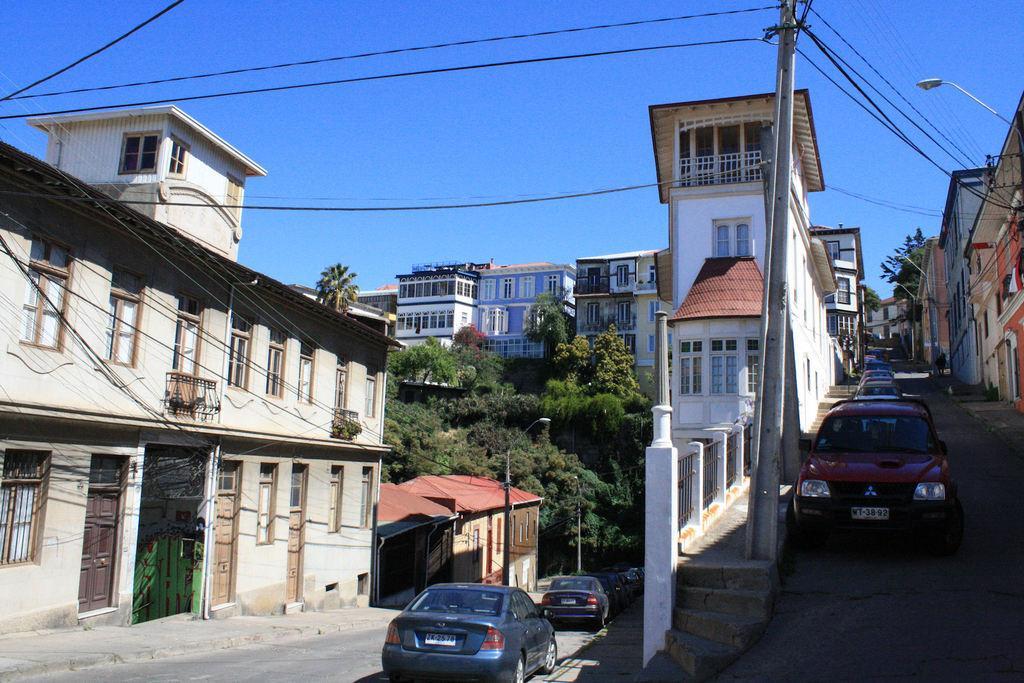In one or two sentences, can you explain what this image depicts? In this image we can see these cars are parked on the side of the road, current pole, wires, buildings, stairs, trees and the blue color sky in the background. 